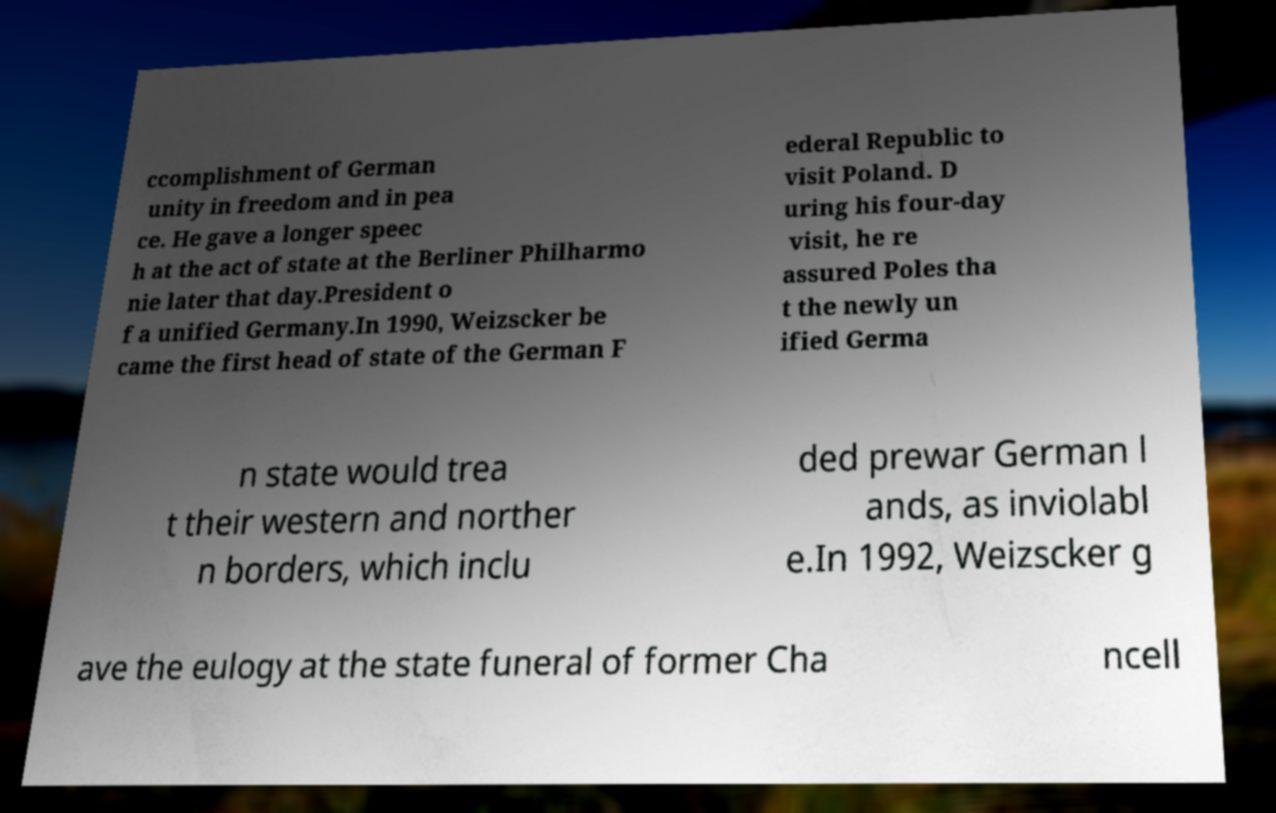I need the written content from this picture converted into text. Can you do that? ccomplishment of German unity in freedom and in pea ce. He gave a longer speec h at the act of state at the Berliner Philharmo nie later that day.President o f a unified Germany.In 1990, Weizscker be came the first head of state of the German F ederal Republic to visit Poland. D uring his four-day visit, he re assured Poles tha t the newly un ified Germa n state would trea t their western and norther n borders, which inclu ded prewar German l ands, as inviolabl e.In 1992, Weizscker g ave the eulogy at the state funeral of former Cha ncell 